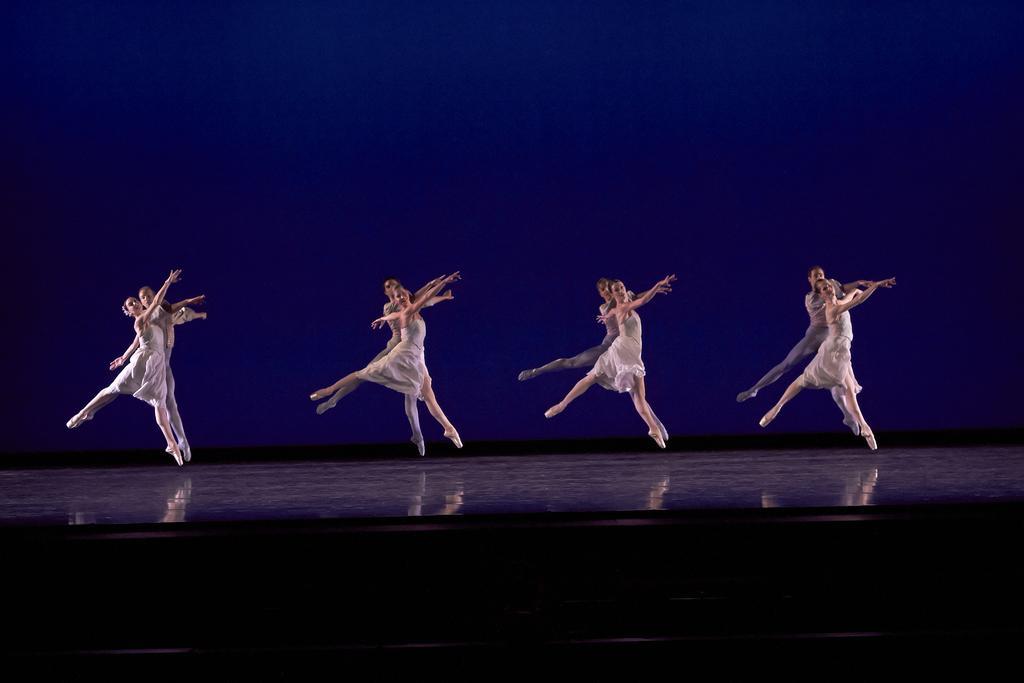In one or two sentences, can you explain what this image depicts? In this image I can see people wearing white dress and dancing on the stage. There is a blue background. 